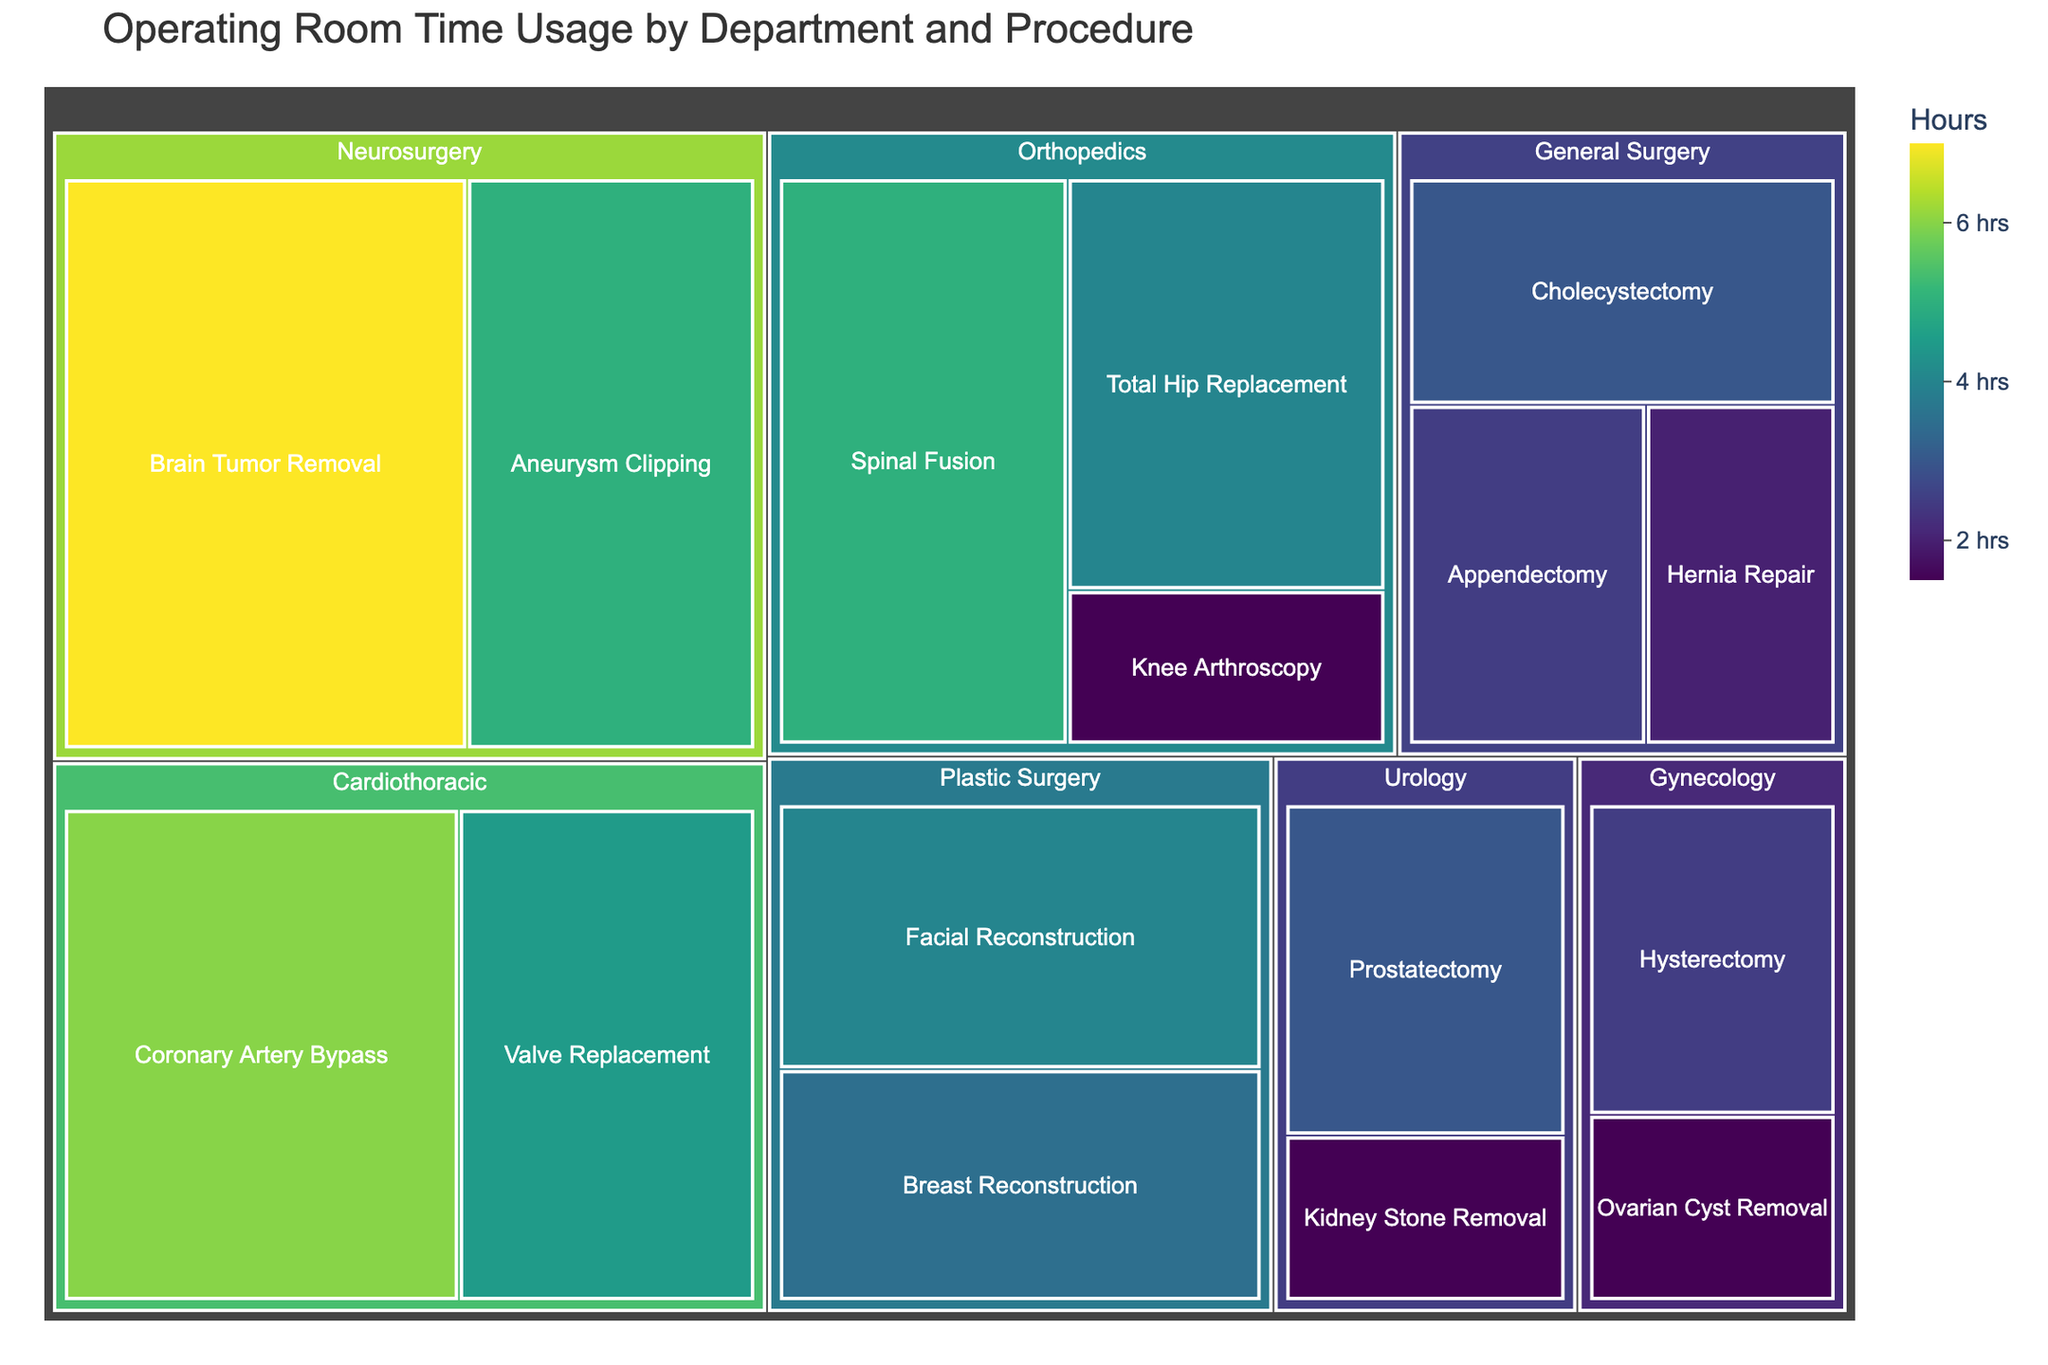What is the title of the treemap? The title is usually found at the top of the figure. By looking at the topmost part of the treemap, you can see the title clearly.
Answer: Operating Room Time Usage by Department and Procedure Which surgical procedure consumes the most operating room time? Identify the largest block in the treemap since it represents the procedure with the highest value. The label on the block will indicate the specific procedure.
Answer: Brain Tumor Removal Which department has the highest combined operating room time for its procedures? Sum up the times for each procedure within each department. The department with the largest aggregate time will stand out more prominently in the treemap.
Answer: Neurosurgery How much time does General Surgery take up in total for all its procedures? Add the times for Appendectomy (2.5 hours), Cholecystectomy (3 hours), and Hernia Repair (2 hours). The sum gives us the total time for General Surgery. 2.5 + 3 + 2 = 7.5 hours.
Answer: 7.5 hours Which procedure in the Orthopedics department takes the least amount of time? Within the Orthopedics department blocks, compare the sizes and labels to find the one with the smallest time.
Answer: Knee Arthroscopy How does the time for Valve Replacement in Cardiothoracic surgery compare to that for Breast Reconstruction in Plastic Surgery? Identify and compare the block sizes or values directly. Valve Replacement is 4.5 hours while Breast Reconstruction is 3.5 hours. 4.5 > 3.5, so Valve Replacement takes more time.
Answer: Valve Replacement takes more time Are there any procedures that take less than 2 hours? If so, list them. Look for the smallest blocks or values in the treemap. Compare these values against 2 hours. Knee Arthroscopy, Kidney Stone Removal, and Ovarian Cyst Removal each take 1.5 hours.
Answer: Knee Arthroscopy, Kidney Stone Removal, Ovarian Cyst Removal Which department has the procedure with the second-longest operating room time? Find the largest block, which is Brain Tumor Removal in Neurosurgery (7 hours). The next largest block belongs to Coronary Artery Bypass in Cardiothoracic (6 hours). Thus, Cardiothoracic is the department of interest.
Answer: Cardiothoracic What is the average operating time for procedures in the Gynecology department? Average the time for Hysterectomy (2.5 hours) and Ovarian Cyst Removal (1.5 hours). \( \frac{2.5 + 1.5}{2} = 2 \) hours
Answer: 2 hours 